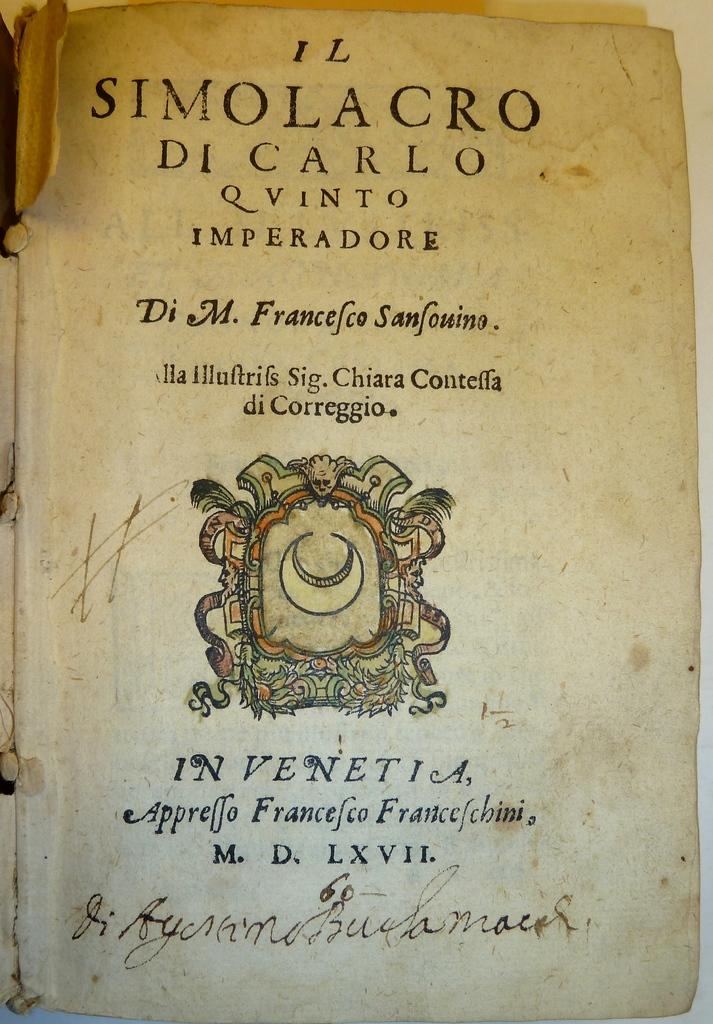What is the title of the book?
Keep it short and to the point. Simolacro di carlo qvinto imperadore. 